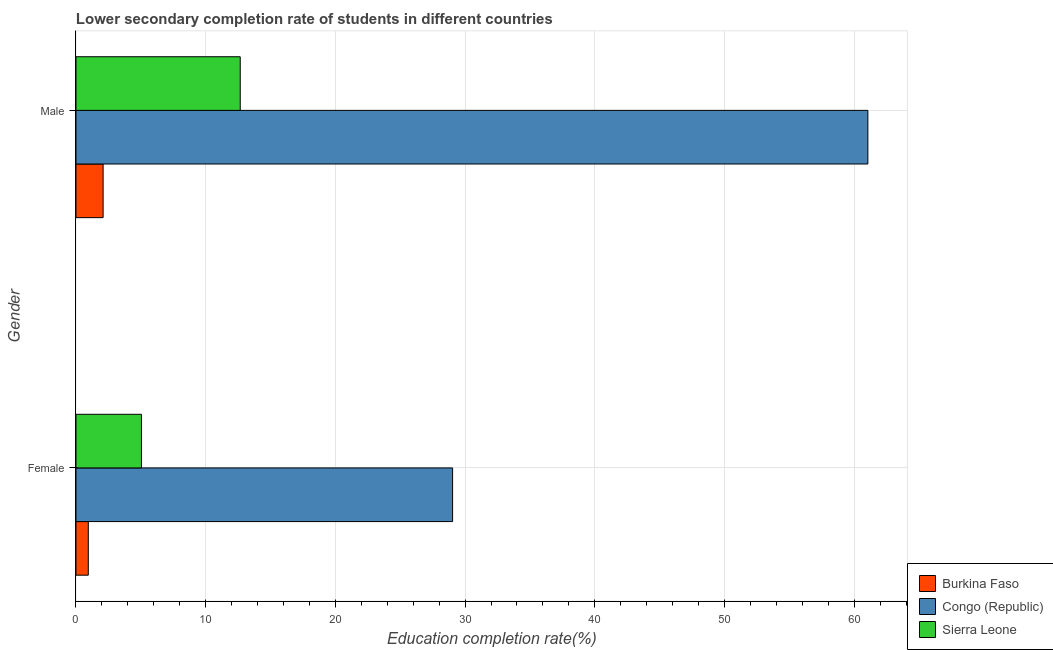How many different coloured bars are there?
Provide a succinct answer. 3. How many groups of bars are there?
Keep it short and to the point. 2. How many bars are there on the 1st tick from the top?
Offer a very short reply. 3. How many bars are there on the 2nd tick from the bottom?
Provide a short and direct response. 3. What is the education completion rate of male students in Burkina Faso?
Offer a terse response. 2.09. Across all countries, what is the maximum education completion rate of female students?
Your answer should be very brief. 29.04. Across all countries, what is the minimum education completion rate of male students?
Your answer should be very brief. 2.09. In which country was the education completion rate of male students maximum?
Provide a succinct answer. Congo (Republic). In which country was the education completion rate of male students minimum?
Your response must be concise. Burkina Faso. What is the total education completion rate of female students in the graph?
Give a very brief answer. 35.03. What is the difference between the education completion rate of male students in Congo (Republic) and that in Sierra Leone?
Your answer should be very brief. 48.4. What is the difference between the education completion rate of male students in Burkina Faso and the education completion rate of female students in Sierra Leone?
Keep it short and to the point. -2.96. What is the average education completion rate of female students per country?
Your response must be concise. 11.68. What is the difference between the education completion rate of male students and education completion rate of female students in Burkina Faso?
Your answer should be compact. 1.14. In how many countries, is the education completion rate of male students greater than 48 %?
Provide a short and direct response. 1. What is the ratio of the education completion rate of female students in Congo (Republic) to that in Sierra Leone?
Provide a succinct answer. 5.75. In how many countries, is the education completion rate of male students greater than the average education completion rate of male students taken over all countries?
Offer a very short reply. 1. What does the 2nd bar from the top in Female represents?
Ensure brevity in your answer.  Congo (Republic). What does the 2nd bar from the bottom in Female represents?
Provide a short and direct response. Congo (Republic). How many countries are there in the graph?
Your answer should be very brief. 3. Are the values on the major ticks of X-axis written in scientific E-notation?
Provide a succinct answer. No. Does the graph contain any zero values?
Provide a short and direct response. No. Does the graph contain grids?
Provide a short and direct response. Yes. Where does the legend appear in the graph?
Your answer should be very brief. Bottom right. How many legend labels are there?
Provide a succinct answer. 3. How are the legend labels stacked?
Offer a very short reply. Vertical. What is the title of the graph?
Ensure brevity in your answer.  Lower secondary completion rate of students in different countries. What is the label or title of the X-axis?
Provide a short and direct response. Education completion rate(%). What is the label or title of the Y-axis?
Provide a succinct answer. Gender. What is the Education completion rate(%) in Burkina Faso in Female?
Give a very brief answer. 0.95. What is the Education completion rate(%) of Congo (Republic) in Female?
Your response must be concise. 29.04. What is the Education completion rate(%) in Sierra Leone in Female?
Offer a very short reply. 5.05. What is the Education completion rate(%) in Burkina Faso in Male?
Your response must be concise. 2.09. What is the Education completion rate(%) of Congo (Republic) in Male?
Offer a terse response. 61.06. What is the Education completion rate(%) in Sierra Leone in Male?
Ensure brevity in your answer.  12.66. Across all Gender, what is the maximum Education completion rate(%) of Burkina Faso?
Offer a very short reply. 2.09. Across all Gender, what is the maximum Education completion rate(%) of Congo (Republic)?
Your response must be concise. 61.06. Across all Gender, what is the maximum Education completion rate(%) of Sierra Leone?
Keep it short and to the point. 12.66. Across all Gender, what is the minimum Education completion rate(%) of Burkina Faso?
Make the answer very short. 0.95. Across all Gender, what is the minimum Education completion rate(%) of Congo (Republic)?
Provide a succinct answer. 29.04. Across all Gender, what is the minimum Education completion rate(%) in Sierra Leone?
Offer a very short reply. 5.05. What is the total Education completion rate(%) in Burkina Faso in the graph?
Offer a very short reply. 3.04. What is the total Education completion rate(%) of Congo (Republic) in the graph?
Keep it short and to the point. 90.1. What is the total Education completion rate(%) in Sierra Leone in the graph?
Make the answer very short. 17.71. What is the difference between the Education completion rate(%) of Burkina Faso in Female and that in Male?
Keep it short and to the point. -1.14. What is the difference between the Education completion rate(%) in Congo (Republic) in Female and that in Male?
Provide a succinct answer. -32.02. What is the difference between the Education completion rate(%) in Sierra Leone in Female and that in Male?
Make the answer very short. -7.62. What is the difference between the Education completion rate(%) in Burkina Faso in Female and the Education completion rate(%) in Congo (Republic) in Male?
Offer a terse response. -60.11. What is the difference between the Education completion rate(%) of Burkina Faso in Female and the Education completion rate(%) of Sierra Leone in Male?
Make the answer very short. -11.71. What is the difference between the Education completion rate(%) in Congo (Republic) in Female and the Education completion rate(%) in Sierra Leone in Male?
Ensure brevity in your answer.  16.37. What is the average Education completion rate(%) in Burkina Faso per Gender?
Your response must be concise. 1.52. What is the average Education completion rate(%) of Congo (Republic) per Gender?
Your response must be concise. 45.05. What is the average Education completion rate(%) of Sierra Leone per Gender?
Offer a terse response. 8.86. What is the difference between the Education completion rate(%) of Burkina Faso and Education completion rate(%) of Congo (Republic) in Female?
Provide a short and direct response. -28.09. What is the difference between the Education completion rate(%) in Burkina Faso and Education completion rate(%) in Sierra Leone in Female?
Keep it short and to the point. -4.1. What is the difference between the Education completion rate(%) of Congo (Republic) and Education completion rate(%) of Sierra Leone in Female?
Provide a short and direct response. 23.99. What is the difference between the Education completion rate(%) in Burkina Faso and Education completion rate(%) in Congo (Republic) in Male?
Your response must be concise. -58.97. What is the difference between the Education completion rate(%) in Burkina Faso and Education completion rate(%) in Sierra Leone in Male?
Make the answer very short. -10.57. What is the difference between the Education completion rate(%) of Congo (Republic) and Education completion rate(%) of Sierra Leone in Male?
Make the answer very short. 48.4. What is the ratio of the Education completion rate(%) of Burkina Faso in Female to that in Male?
Make the answer very short. 0.45. What is the ratio of the Education completion rate(%) of Congo (Republic) in Female to that in Male?
Your answer should be very brief. 0.48. What is the ratio of the Education completion rate(%) of Sierra Leone in Female to that in Male?
Make the answer very short. 0.4. What is the difference between the highest and the second highest Education completion rate(%) of Burkina Faso?
Offer a terse response. 1.14. What is the difference between the highest and the second highest Education completion rate(%) of Congo (Republic)?
Your response must be concise. 32.02. What is the difference between the highest and the second highest Education completion rate(%) of Sierra Leone?
Give a very brief answer. 7.62. What is the difference between the highest and the lowest Education completion rate(%) in Burkina Faso?
Offer a very short reply. 1.14. What is the difference between the highest and the lowest Education completion rate(%) in Congo (Republic)?
Your response must be concise. 32.02. What is the difference between the highest and the lowest Education completion rate(%) of Sierra Leone?
Your response must be concise. 7.62. 